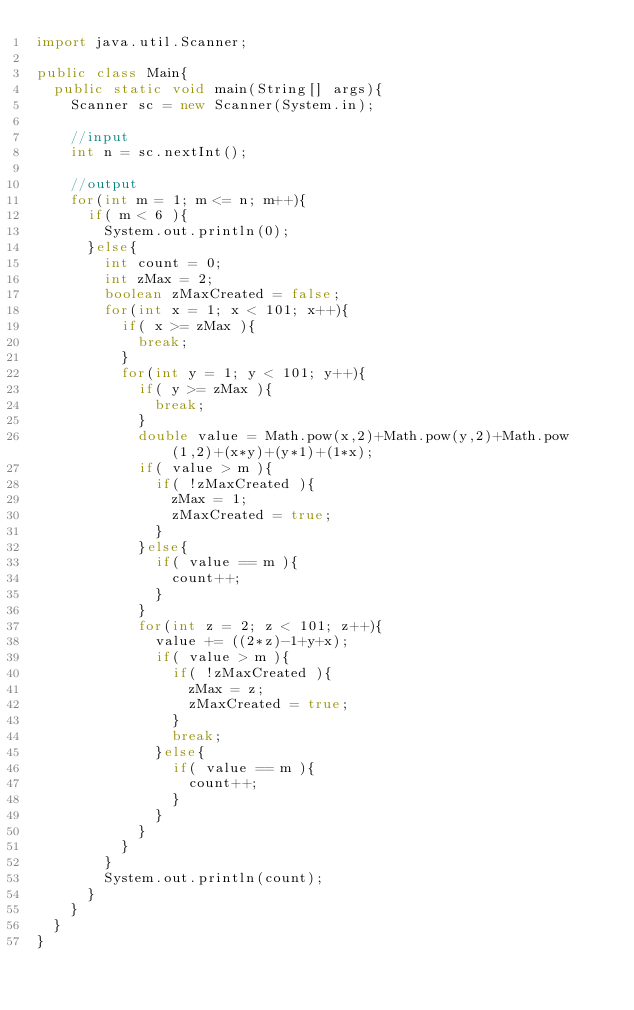Convert code to text. <code><loc_0><loc_0><loc_500><loc_500><_Java_>import java.util.Scanner;

public class Main{
  public static void main(String[] args){
    Scanner sc = new Scanner(System.in);

    //input
    int n = sc.nextInt();

    //output
    for(int m = 1; m <= n; m++){
      if( m < 6 ){
        System.out.println(0);
      }else{
        int count = 0;
        int zMax = 2;
        boolean zMaxCreated = false;
        for(int x = 1; x < 101; x++){
          if( x >= zMax ){
            break;
          }
          for(int y = 1; y < 101; y++){
            if( y >= zMax ){
              break;
            }
            double value = Math.pow(x,2)+Math.pow(y,2)+Math.pow(1,2)+(x*y)+(y*1)+(1*x);
            if( value > m ){
              if( !zMaxCreated ){
                zMax = 1;
                zMaxCreated = true;
              }
            }else{
              if( value == m ){
                count++;
              }
            }
            for(int z = 2; z < 101; z++){
              value += ((2*z)-1+y+x);
              if( value > m ){
                if( !zMaxCreated ){
                  zMax = z;
                  zMaxCreated = true;
                }
                break;
              }else{
                if( value == m ){
                  count++;
                }
              }
            }
          }
        }
        System.out.println(count);
      }
    }
  }
}
</code> 